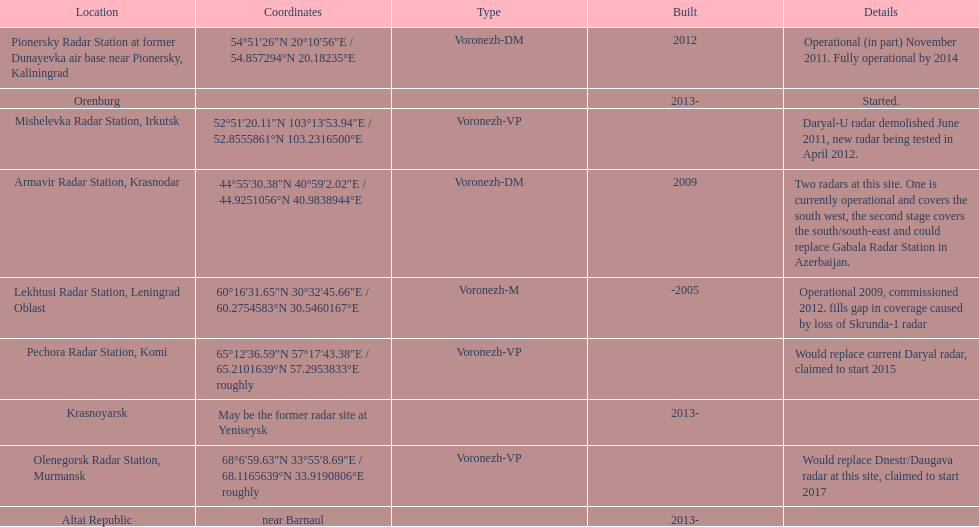What year built is at the top? -2005. 